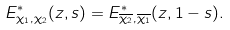Convert formula to latex. <formula><loc_0><loc_0><loc_500><loc_500>E ^ { * } _ { \chi _ { 1 } , \chi _ { 2 } } ( z , s ) = E ^ { * } _ { \overline { \chi _ { 2 } } , \overline { \chi _ { 1 } } } ( z , 1 - s ) .</formula> 